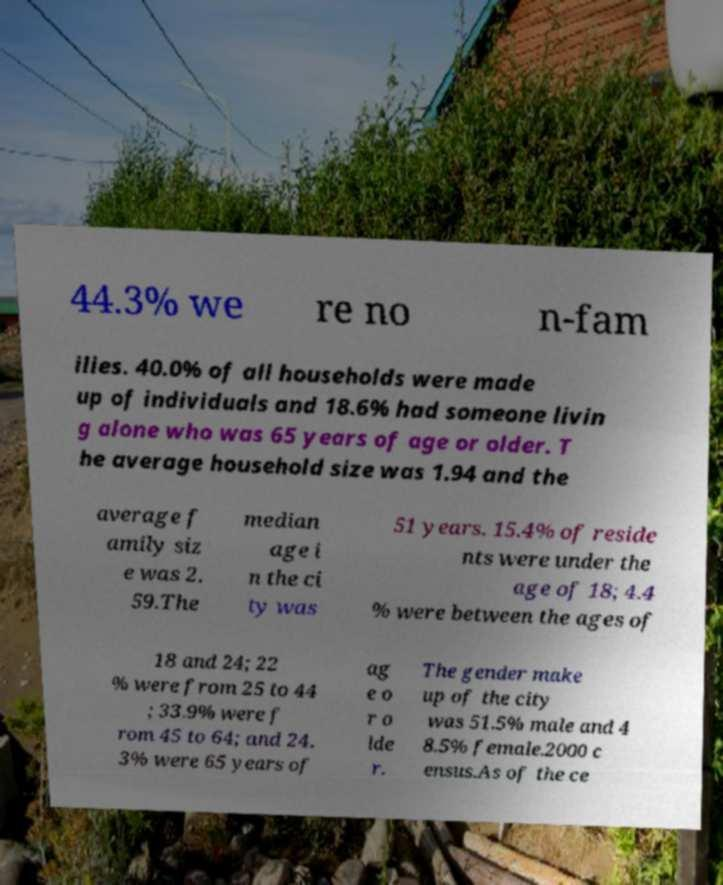What messages or text are displayed in this image? I need them in a readable, typed format. 44.3% we re no n-fam ilies. 40.0% of all households were made up of individuals and 18.6% had someone livin g alone who was 65 years of age or older. T he average household size was 1.94 and the average f amily siz e was 2. 59.The median age i n the ci ty was 51 years. 15.4% of reside nts were under the age of 18; 4.4 % were between the ages of 18 and 24; 22 % were from 25 to 44 ; 33.9% were f rom 45 to 64; and 24. 3% were 65 years of ag e o r o lde r. The gender make up of the city was 51.5% male and 4 8.5% female.2000 c ensus.As of the ce 